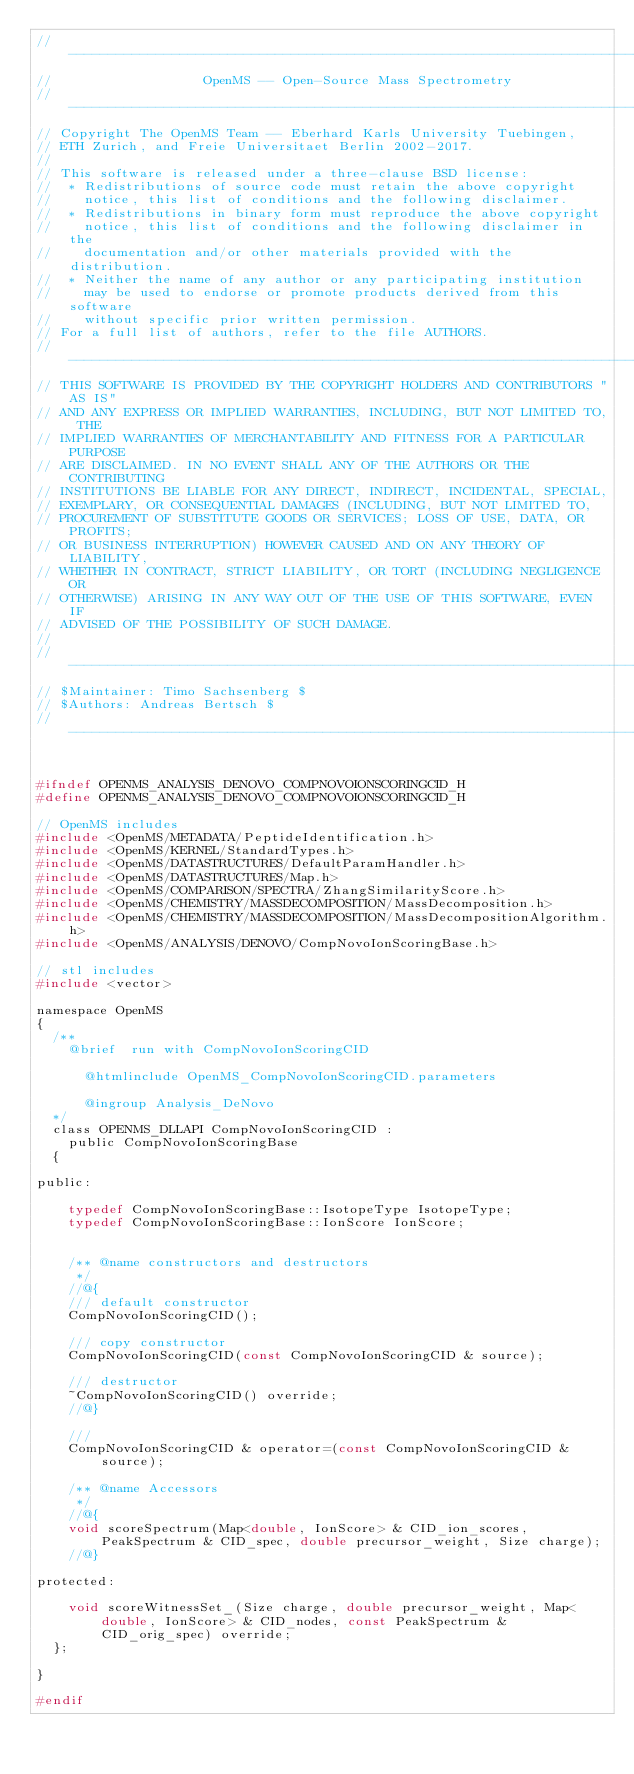Convert code to text. <code><loc_0><loc_0><loc_500><loc_500><_C_>// --------------------------------------------------------------------------
//                   OpenMS -- Open-Source Mass Spectrometry
// --------------------------------------------------------------------------
// Copyright The OpenMS Team -- Eberhard Karls University Tuebingen,
// ETH Zurich, and Freie Universitaet Berlin 2002-2017.
//
// This software is released under a three-clause BSD license:
//  * Redistributions of source code must retain the above copyright
//    notice, this list of conditions and the following disclaimer.
//  * Redistributions in binary form must reproduce the above copyright
//    notice, this list of conditions and the following disclaimer in the
//    documentation and/or other materials provided with the distribution.
//  * Neither the name of any author or any participating institution
//    may be used to endorse or promote products derived from this software
//    without specific prior written permission.
// For a full list of authors, refer to the file AUTHORS.
// --------------------------------------------------------------------------
// THIS SOFTWARE IS PROVIDED BY THE COPYRIGHT HOLDERS AND CONTRIBUTORS "AS IS"
// AND ANY EXPRESS OR IMPLIED WARRANTIES, INCLUDING, BUT NOT LIMITED TO, THE
// IMPLIED WARRANTIES OF MERCHANTABILITY AND FITNESS FOR A PARTICULAR PURPOSE
// ARE DISCLAIMED. IN NO EVENT SHALL ANY OF THE AUTHORS OR THE CONTRIBUTING
// INSTITUTIONS BE LIABLE FOR ANY DIRECT, INDIRECT, INCIDENTAL, SPECIAL,
// EXEMPLARY, OR CONSEQUENTIAL DAMAGES (INCLUDING, BUT NOT LIMITED TO,
// PROCUREMENT OF SUBSTITUTE GOODS OR SERVICES; LOSS OF USE, DATA, OR PROFITS;
// OR BUSINESS INTERRUPTION) HOWEVER CAUSED AND ON ANY THEORY OF LIABILITY,
// WHETHER IN CONTRACT, STRICT LIABILITY, OR TORT (INCLUDING NEGLIGENCE OR
// OTHERWISE) ARISING IN ANY WAY OUT OF THE USE OF THIS SOFTWARE, EVEN IF
// ADVISED OF THE POSSIBILITY OF SUCH DAMAGE.
//
// --------------------------------------------------------------------------
// $Maintainer: Timo Sachsenberg $
// $Authors: Andreas Bertsch $
// --------------------------------------------------------------------------


#ifndef OPENMS_ANALYSIS_DENOVO_COMPNOVOIONSCORINGCID_H
#define OPENMS_ANALYSIS_DENOVO_COMPNOVOIONSCORINGCID_H

// OpenMS includes
#include <OpenMS/METADATA/PeptideIdentification.h>
#include <OpenMS/KERNEL/StandardTypes.h>
#include <OpenMS/DATASTRUCTURES/DefaultParamHandler.h>
#include <OpenMS/DATASTRUCTURES/Map.h>
#include <OpenMS/COMPARISON/SPECTRA/ZhangSimilarityScore.h>
#include <OpenMS/CHEMISTRY/MASSDECOMPOSITION/MassDecomposition.h>
#include <OpenMS/CHEMISTRY/MASSDECOMPOSITION/MassDecompositionAlgorithm.h>
#include <OpenMS/ANALYSIS/DENOVO/CompNovoIonScoringBase.h>

// stl includes
#include <vector>

namespace OpenMS
{
  /**
    @brief  run with CompNovoIonScoringCID

      @htmlinclude OpenMS_CompNovoIonScoringCID.parameters

      @ingroup Analysis_DeNovo
  */
  class OPENMS_DLLAPI CompNovoIonScoringCID :
    public CompNovoIonScoringBase
  {

public:

    typedef CompNovoIonScoringBase::IsotopeType IsotopeType;
    typedef CompNovoIonScoringBase::IonScore IonScore;


    /** @name constructors and destructors
     */
    //@{
    /// default constructor
    CompNovoIonScoringCID();

    /// copy constructor
    CompNovoIonScoringCID(const CompNovoIonScoringCID & source);

    /// destructor
    ~CompNovoIonScoringCID() override;
    //@}

    ///
    CompNovoIonScoringCID & operator=(const CompNovoIonScoringCID & source);

    /** @name Accessors
     */
    //@{
    void scoreSpectrum(Map<double, IonScore> & CID_ion_scores, PeakSpectrum & CID_spec, double precursor_weight, Size charge);
    //@}

protected:

    void scoreWitnessSet_(Size charge, double precursor_weight, Map<double, IonScore> & CID_nodes, const PeakSpectrum & CID_orig_spec) override;
  };

}

#endif
</code> 